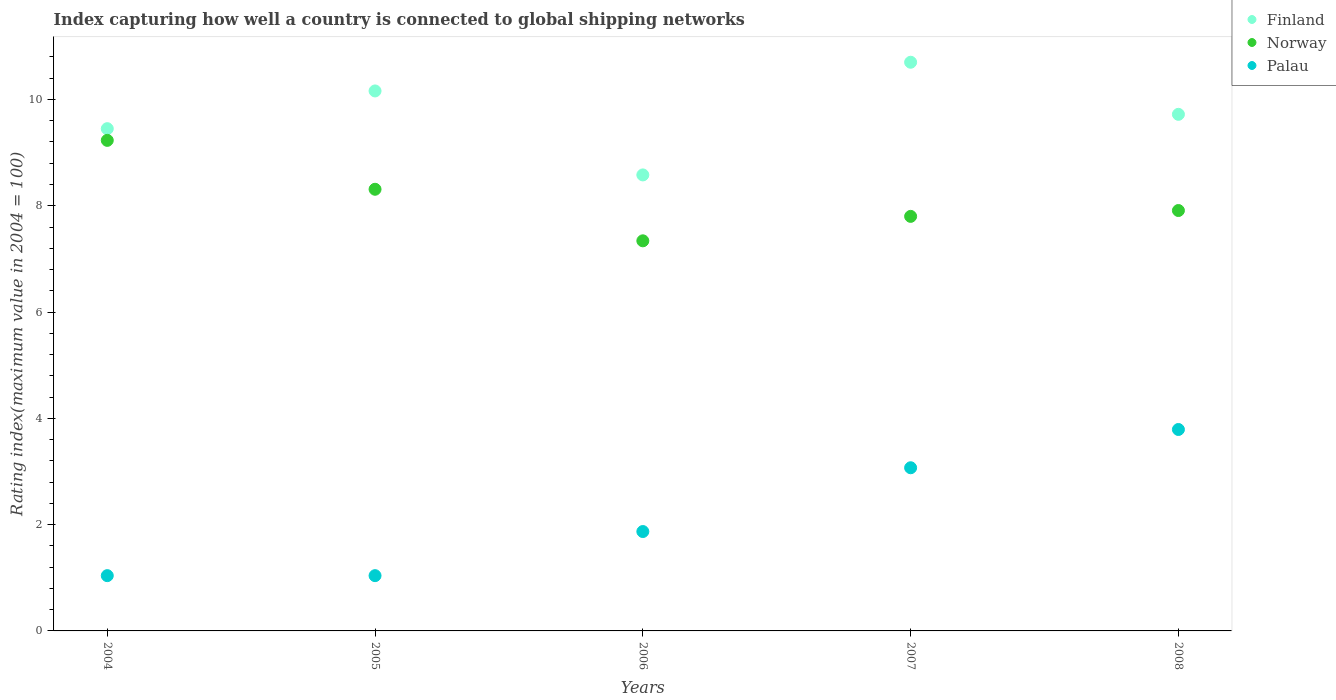What is the rating index in Finland in 2008?
Offer a terse response. 9.72. Across all years, what is the maximum rating index in Norway?
Offer a very short reply. 9.23. Across all years, what is the minimum rating index in Norway?
Provide a short and direct response. 7.34. What is the total rating index in Finland in the graph?
Offer a very short reply. 48.61. What is the difference between the rating index in Finland in 2005 and that in 2006?
Keep it short and to the point. 1.58. What is the difference between the rating index in Palau in 2004 and the rating index in Norway in 2008?
Your response must be concise. -6.87. What is the average rating index in Palau per year?
Provide a succinct answer. 2.16. In the year 2005, what is the difference between the rating index in Finland and rating index in Norway?
Your answer should be very brief. 1.85. What is the ratio of the rating index in Palau in 2004 to that in 2007?
Offer a very short reply. 0.34. Is the rating index in Norway in 2005 less than that in 2008?
Your response must be concise. No. What is the difference between the highest and the second highest rating index in Norway?
Offer a terse response. 0.92. What is the difference between the highest and the lowest rating index in Finland?
Your answer should be compact. 2.12. Does the rating index in Finland monotonically increase over the years?
Ensure brevity in your answer.  No. Is the rating index in Palau strictly greater than the rating index in Finland over the years?
Make the answer very short. No. Is the rating index in Finland strictly less than the rating index in Norway over the years?
Offer a terse response. No. Are the values on the major ticks of Y-axis written in scientific E-notation?
Your answer should be very brief. No. Where does the legend appear in the graph?
Ensure brevity in your answer.  Top right. How are the legend labels stacked?
Ensure brevity in your answer.  Vertical. What is the title of the graph?
Your answer should be compact. Index capturing how well a country is connected to global shipping networks. Does "Tonga" appear as one of the legend labels in the graph?
Your answer should be very brief. No. What is the label or title of the X-axis?
Your answer should be very brief. Years. What is the label or title of the Y-axis?
Offer a very short reply. Rating index(maximum value in 2004 = 100). What is the Rating index(maximum value in 2004 = 100) of Finland in 2004?
Give a very brief answer. 9.45. What is the Rating index(maximum value in 2004 = 100) of Norway in 2004?
Give a very brief answer. 9.23. What is the Rating index(maximum value in 2004 = 100) in Finland in 2005?
Your answer should be very brief. 10.16. What is the Rating index(maximum value in 2004 = 100) of Norway in 2005?
Offer a very short reply. 8.31. What is the Rating index(maximum value in 2004 = 100) of Finland in 2006?
Keep it short and to the point. 8.58. What is the Rating index(maximum value in 2004 = 100) of Norway in 2006?
Provide a succinct answer. 7.34. What is the Rating index(maximum value in 2004 = 100) of Palau in 2006?
Offer a terse response. 1.87. What is the Rating index(maximum value in 2004 = 100) in Palau in 2007?
Keep it short and to the point. 3.07. What is the Rating index(maximum value in 2004 = 100) of Finland in 2008?
Provide a succinct answer. 9.72. What is the Rating index(maximum value in 2004 = 100) of Norway in 2008?
Ensure brevity in your answer.  7.91. What is the Rating index(maximum value in 2004 = 100) of Palau in 2008?
Your answer should be compact. 3.79. Across all years, what is the maximum Rating index(maximum value in 2004 = 100) in Finland?
Offer a terse response. 10.7. Across all years, what is the maximum Rating index(maximum value in 2004 = 100) of Norway?
Give a very brief answer. 9.23. Across all years, what is the maximum Rating index(maximum value in 2004 = 100) of Palau?
Your response must be concise. 3.79. Across all years, what is the minimum Rating index(maximum value in 2004 = 100) of Finland?
Provide a short and direct response. 8.58. Across all years, what is the minimum Rating index(maximum value in 2004 = 100) in Norway?
Provide a succinct answer. 7.34. Across all years, what is the minimum Rating index(maximum value in 2004 = 100) of Palau?
Your response must be concise. 1.04. What is the total Rating index(maximum value in 2004 = 100) in Finland in the graph?
Offer a terse response. 48.61. What is the total Rating index(maximum value in 2004 = 100) of Norway in the graph?
Provide a succinct answer. 40.59. What is the total Rating index(maximum value in 2004 = 100) of Palau in the graph?
Offer a very short reply. 10.81. What is the difference between the Rating index(maximum value in 2004 = 100) of Finland in 2004 and that in 2005?
Your answer should be compact. -0.71. What is the difference between the Rating index(maximum value in 2004 = 100) in Norway in 2004 and that in 2005?
Offer a very short reply. 0.92. What is the difference between the Rating index(maximum value in 2004 = 100) in Palau in 2004 and that in 2005?
Offer a very short reply. 0. What is the difference between the Rating index(maximum value in 2004 = 100) of Finland in 2004 and that in 2006?
Give a very brief answer. 0.87. What is the difference between the Rating index(maximum value in 2004 = 100) in Norway in 2004 and that in 2006?
Make the answer very short. 1.89. What is the difference between the Rating index(maximum value in 2004 = 100) in Palau in 2004 and that in 2006?
Your answer should be compact. -0.83. What is the difference between the Rating index(maximum value in 2004 = 100) of Finland in 2004 and that in 2007?
Provide a succinct answer. -1.25. What is the difference between the Rating index(maximum value in 2004 = 100) of Norway in 2004 and that in 2007?
Make the answer very short. 1.43. What is the difference between the Rating index(maximum value in 2004 = 100) of Palau in 2004 and that in 2007?
Keep it short and to the point. -2.03. What is the difference between the Rating index(maximum value in 2004 = 100) in Finland in 2004 and that in 2008?
Give a very brief answer. -0.27. What is the difference between the Rating index(maximum value in 2004 = 100) in Norway in 2004 and that in 2008?
Your response must be concise. 1.32. What is the difference between the Rating index(maximum value in 2004 = 100) in Palau in 2004 and that in 2008?
Offer a terse response. -2.75. What is the difference between the Rating index(maximum value in 2004 = 100) in Finland in 2005 and that in 2006?
Your answer should be very brief. 1.58. What is the difference between the Rating index(maximum value in 2004 = 100) in Palau in 2005 and that in 2006?
Keep it short and to the point. -0.83. What is the difference between the Rating index(maximum value in 2004 = 100) in Finland in 2005 and that in 2007?
Offer a terse response. -0.54. What is the difference between the Rating index(maximum value in 2004 = 100) of Norway in 2005 and that in 2007?
Offer a terse response. 0.51. What is the difference between the Rating index(maximum value in 2004 = 100) in Palau in 2005 and that in 2007?
Ensure brevity in your answer.  -2.03. What is the difference between the Rating index(maximum value in 2004 = 100) in Finland in 2005 and that in 2008?
Ensure brevity in your answer.  0.44. What is the difference between the Rating index(maximum value in 2004 = 100) of Palau in 2005 and that in 2008?
Your response must be concise. -2.75. What is the difference between the Rating index(maximum value in 2004 = 100) in Finland in 2006 and that in 2007?
Provide a short and direct response. -2.12. What is the difference between the Rating index(maximum value in 2004 = 100) in Norway in 2006 and that in 2007?
Your response must be concise. -0.46. What is the difference between the Rating index(maximum value in 2004 = 100) of Finland in 2006 and that in 2008?
Keep it short and to the point. -1.14. What is the difference between the Rating index(maximum value in 2004 = 100) in Norway in 2006 and that in 2008?
Provide a succinct answer. -0.57. What is the difference between the Rating index(maximum value in 2004 = 100) in Palau in 2006 and that in 2008?
Offer a terse response. -1.92. What is the difference between the Rating index(maximum value in 2004 = 100) in Norway in 2007 and that in 2008?
Keep it short and to the point. -0.11. What is the difference between the Rating index(maximum value in 2004 = 100) in Palau in 2007 and that in 2008?
Offer a terse response. -0.72. What is the difference between the Rating index(maximum value in 2004 = 100) in Finland in 2004 and the Rating index(maximum value in 2004 = 100) in Norway in 2005?
Provide a succinct answer. 1.14. What is the difference between the Rating index(maximum value in 2004 = 100) of Finland in 2004 and the Rating index(maximum value in 2004 = 100) of Palau in 2005?
Ensure brevity in your answer.  8.41. What is the difference between the Rating index(maximum value in 2004 = 100) of Norway in 2004 and the Rating index(maximum value in 2004 = 100) of Palau in 2005?
Provide a short and direct response. 8.19. What is the difference between the Rating index(maximum value in 2004 = 100) in Finland in 2004 and the Rating index(maximum value in 2004 = 100) in Norway in 2006?
Offer a very short reply. 2.11. What is the difference between the Rating index(maximum value in 2004 = 100) in Finland in 2004 and the Rating index(maximum value in 2004 = 100) in Palau in 2006?
Ensure brevity in your answer.  7.58. What is the difference between the Rating index(maximum value in 2004 = 100) of Norway in 2004 and the Rating index(maximum value in 2004 = 100) of Palau in 2006?
Provide a short and direct response. 7.36. What is the difference between the Rating index(maximum value in 2004 = 100) of Finland in 2004 and the Rating index(maximum value in 2004 = 100) of Norway in 2007?
Your answer should be compact. 1.65. What is the difference between the Rating index(maximum value in 2004 = 100) in Finland in 2004 and the Rating index(maximum value in 2004 = 100) in Palau in 2007?
Give a very brief answer. 6.38. What is the difference between the Rating index(maximum value in 2004 = 100) of Norway in 2004 and the Rating index(maximum value in 2004 = 100) of Palau in 2007?
Provide a succinct answer. 6.16. What is the difference between the Rating index(maximum value in 2004 = 100) in Finland in 2004 and the Rating index(maximum value in 2004 = 100) in Norway in 2008?
Give a very brief answer. 1.54. What is the difference between the Rating index(maximum value in 2004 = 100) in Finland in 2004 and the Rating index(maximum value in 2004 = 100) in Palau in 2008?
Give a very brief answer. 5.66. What is the difference between the Rating index(maximum value in 2004 = 100) in Norway in 2004 and the Rating index(maximum value in 2004 = 100) in Palau in 2008?
Your answer should be very brief. 5.44. What is the difference between the Rating index(maximum value in 2004 = 100) in Finland in 2005 and the Rating index(maximum value in 2004 = 100) in Norway in 2006?
Your answer should be compact. 2.82. What is the difference between the Rating index(maximum value in 2004 = 100) of Finland in 2005 and the Rating index(maximum value in 2004 = 100) of Palau in 2006?
Keep it short and to the point. 8.29. What is the difference between the Rating index(maximum value in 2004 = 100) of Norway in 2005 and the Rating index(maximum value in 2004 = 100) of Palau in 2006?
Keep it short and to the point. 6.44. What is the difference between the Rating index(maximum value in 2004 = 100) of Finland in 2005 and the Rating index(maximum value in 2004 = 100) of Norway in 2007?
Give a very brief answer. 2.36. What is the difference between the Rating index(maximum value in 2004 = 100) in Finland in 2005 and the Rating index(maximum value in 2004 = 100) in Palau in 2007?
Ensure brevity in your answer.  7.09. What is the difference between the Rating index(maximum value in 2004 = 100) of Norway in 2005 and the Rating index(maximum value in 2004 = 100) of Palau in 2007?
Provide a short and direct response. 5.24. What is the difference between the Rating index(maximum value in 2004 = 100) of Finland in 2005 and the Rating index(maximum value in 2004 = 100) of Norway in 2008?
Your response must be concise. 2.25. What is the difference between the Rating index(maximum value in 2004 = 100) in Finland in 2005 and the Rating index(maximum value in 2004 = 100) in Palau in 2008?
Ensure brevity in your answer.  6.37. What is the difference between the Rating index(maximum value in 2004 = 100) of Norway in 2005 and the Rating index(maximum value in 2004 = 100) of Palau in 2008?
Provide a succinct answer. 4.52. What is the difference between the Rating index(maximum value in 2004 = 100) of Finland in 2006 and the Rating index(maximum value in 2004 = 100) of Norway in 2007?
Your response must be concise. 0.78. What is the difference between the Rating index(maximum value in 2004 = 100) of Finland in 2006 and the Rating index(maximum value in 2004 = 100) of Palau in 2007?
Offer a terse response. 5.51. What is the difference between the Rating index(maximum value in 2004 = 100) in Norway in 2006 and the Rating index(maximum value in 2004 = 100) in Palau in 2007?
Offer a terse response. 4.27. What is the difference between the Rating index(maximum value in 2004 = 100) of Finland in 2006 and the Rating index(maximum value in 2004 = 100) of Norway in 2008?
Offer a very short reply. 0.67. What is the difference between the Rating index(maximum value in 2004 = 100) of Finland in 2006 and the Rating index(maximum value in 2004 = 100) of Palau in 2008?
Make the answer very short. 4.79. What is the difference between the Rating index(maximum value in 2004 = 100) in Norway in 2006 and the Rating index(maximum value in 2004 = 100) in Palau in 2008?
Provide a succinct answer. 3.55. What is the difference between the Rating index(maximum value in 2004 = 100) of Finland in 2007 and the Rating index(maximum value in 2004 = 100) of Norway in 2008?
Your response must be concise. 2.79. What is the difference between the Rating index(maximum value in 2004 = 100) of Finland in 2007 and the Rating index(maximum value in 2004 = 100) of Palau in 2008?
Ensure brevity in your answer.  6.91. What is the difference between the Rating index(maximum value in 2004 = 100) of Norway in 2007 and the Rating index(maximum value in 2004 = 100) of Palau in 2008?
Make the answer very short. 4.01. What is the average Rating index(maximum value in 2004 = 100) of Finland per year?
Make the answer very short. 9.72. What is the average Rating index(maximum value in 2004 = 100) in Norway per year?
Your response must be concise. 8.12. What is the average Rating index(maximum value in 2004 = 100) of Palau per year?
Your answer should be compact. 2.16. In the year 2004, what is the difference between the Rating index(maximum value in 2004 = 100) of Finland and Rating index(maximum value in 2004 = 100) of Norway?
Offer a terse response. 0.22. In the year 2004, what is the difference between the Rating index(maximum value in 2004 = 100) of Finland and Rating index(maximum value in 2004 = 100) of Palau?
Make the answer very short. 8.41. In the year 2004, what is the difference between the Rating index(maximum value in 2004 = 100) of Norway and Rating index(maximum value in 2004 = 100) of Palau?
Give a very brief answer. 8.19. In the year 2005, what is the difference between the Rating index(maximum value in 2004 = 100) of Finland and Rating index(maximum value in 2004 = 100) of Norway?
Give a very brief answer. 1.85. In the year 2005, what is the difference between the Rating index(maximum value in 2004 = 100) of Finland and Rating index(maximum value in 2004 = 100) of Palau?
Your answer should be very brief. 9.12. In the year 2005, what is the difference between the Rating index(maximum value in 2004 = 100) in Norway and Rating index(maximum value in 2004 = 100) in Palau?
Offer a terse response. 7.27. In the year 2006, what is the difference between the Rating index(maximum value in 2004 = 100) of Finland and Rating index(maximum value in 2004 = 100) of Norway?
Keep it short and to the point. 1.24. In the year 2006, what is the difference between the Rating index(maximum value in 2004 = 100) of Finland and Rating index(maximum value in 2004 = 100) of Palau?
Your response must be concise. 6.71. In the year 2006, what is the difference between the Rating index(maximum value in 2004 = 100) of Norway and Rating index(maximum value in 2004 = 100) of Palau?
Your answer should be very brief. 5.47. In the year 2007, what is the difference between the Rating index(maximum value in 2004 = 100) of Finland and Rating index(maximum value in 2004 = 100) of Palau?
Offer a very short reply. 7.63. In the year 2007, what is the difference between the Rating index(maximum value in 2004 = 100) of Norway and Rating index(maximum value in 2004 = 100) of Palau?
Give a very brief answer. 4.73. In the year 2008, what is the difference between the Rating index(maximum value in 2004 = 100) in Finland and Rating index(maximum value in 2004 = 100) in Norway?
Keep it short and to the point. 1.81. In the year 2008, what is the difference between the Rating index(maximum value in 2004 = 100) of Finland and Rating index(maximum value in 2004 = 100) of Palau?
Offer a terse response. 5.93. In the year 2008, what is the difference between the Rating index(maximum value in 2004 = 100) of Norway and Rating index(maximum value in 2004 = 100) of Palau?
Your response must be concise. 4.12. What is the ratio of the Rating index(maximum value in 2004 = 100) in Finland in 2004 to that in 2005?
Offer a terse response. 0.93. What is the ratio of the Rating index(maximum value in 2004 = 100) in Norway in 2004 to that in 2005?
Ensure brevity in your answer.  1.11. What is the ratio of the Rating index(maximum value in 2004 = 100) of Finland in 2004 to that in 2006?
Provide a short and direct response. 1.1. What is the ratio of the Rating index(maximum value in 2004 = 100) in Norway in 2004 to that in 2006?
Make the answer very short. 1.26. What is the ratio of the Rating index(maximum value in 2004 = 100) in Palau in 2004 to that in 2006?
Provide a succinct answer. 0.56. What is the ratio of the Rating index(maximum value in 2004 = 100) of Finland in 2004 to that in 2007?
Your answer should be compact. 0.88. What is the ratio of the Rating index(maximum value in 2004 = 100) in Norway in 2004 to that in 2007?
Your answer should be very brief. 1.18. What is the ratio of the Rating index(maximum value in 2004 = 100) of Palau in 2004 to that in 2007?
Give a very brief answer. 0.34. What is the ratio of the Rating index(maximum value in 2004 = 100) in Finland in 2004 to that in 2008?
Ensure brevity in your answer.  0.97. What is the ratio of the Rating index(maximum value in 2004 = 100) in Norway in 2004 to that in 2008?
Give a very brief answer. 1.17. What is the ratio of the Rating index(maximum value in 2004 = 100) in Palau in 2004 to that in 2008?
Your answer should be very brief. 0.27. What is the ratio of the Rating index(maximum value in 2004 = 100) in Finland in 2005 to that in 2006?
Your answer should be compact. 1.18. What is the ratio of the Rating index(maximum value in 2004 = 100) in Norway in 2005 to that in 2006?
Make the answer very short. 1.13. What is the ratio of the Rating index(maximum value in 2004 = 100) in Palau in 2005 to that in 2006?
Your answer should be compact. 0.56. What is the ratio of the Rating index(maximum value in 2004 = 100) in Finland in 2005 to that in 2007?
Keep it short and to the point. 0.95. What is the ratio of the Rating index(maximum value in 2004 = 100) in Norway in 2005 to that in 2007?
Your answer should be compact. 1.07. What is the ratio of the Rating index(maximum value in 2004 = 100) of Palau in 2005 to that in 2007?
Ensure brevity in your answer.  0.34. What is the ratio of the Rating index(maximum value in 2004 = 100) of Finland in 2005 to that in 2008?
Your answer should be very brief. 1.05. What is the ratio of the Rating index(maximum value in 2004 = 100) of Norway in 2005 to that in 2008?
Make the answer very short. 1.05. What is the ratio of the Rating index(maximum value in 2004 = 100) of Palau in 2005 to that in 2008?
Make the answer very short. 0.27. What is the ratio of the Rating index(maximum value in 2004 = 100) in Finland in 2006 to that in 2007?
Provide a short and direct response. 0.8. What is the ratio of the Rating index(maximum value in 2004 = 100) in Norway in 2006 to that in 2007?
Ensure brevity in your answer.  0.94. What is the ratio of the Rating index(maximum value in 2004 = 100) in Palau in 2006 to that in 2007?
Make the answer very short. 0.61. What is the ratio of the Rating index(maximum value in 2004 = 100) in Finland in 2006 to that in 2008?
Your answer should be very brief. 0.88. What is the ratio of the Rating index(maximum value in 2004 = 100) in Norway in 2006 to that in 2008?
Offer a very short reply. 0.93. What is the ratio of the Rating index(maximum value in 2004 = 100) of Palau in 2006 to that in 2008?
Give a very brief answer. 0.49. What is the ratio of the Rating index(maximum value in 2004 = 100) in Finland in 2007 to that in 2008?
Give a very brief answer. 1.1. What is the ratio of the Rating index(maximum value in 2004 = 100) of Norway in 2007 to that in 2008?
Your answer should be very brief. 0.99. What is the ratio of the Rating index(maximum value in 2004 = 100) of Palau in 2007 to that in 2008?
Your answer should be very brief. 0.81. What is the difference between the highest and the second highest Rating index(maximum value in 2004 = 100) in Finland?
Provide a short and direct response. 0.54. What is the difference between the highest and the second highest Rating index(maximum value in 2004 = 100) in Palau?
Provide a succinct answer. 0.72. What is the difference between the highest and the lowest Rating index(maximum value in 2004 = 100) in Finland?
Offer a terse response. 2.12. What is the difference between the highest and the lowest Rating index(maximum value in 2004 = 100) in Norway?
Your answer should be compact. 1.89. What is the difference between the highest and the lowest Rating index(maximum value in 2004 = 100) in Palau?
Your answer should be very brief. 2.75. 